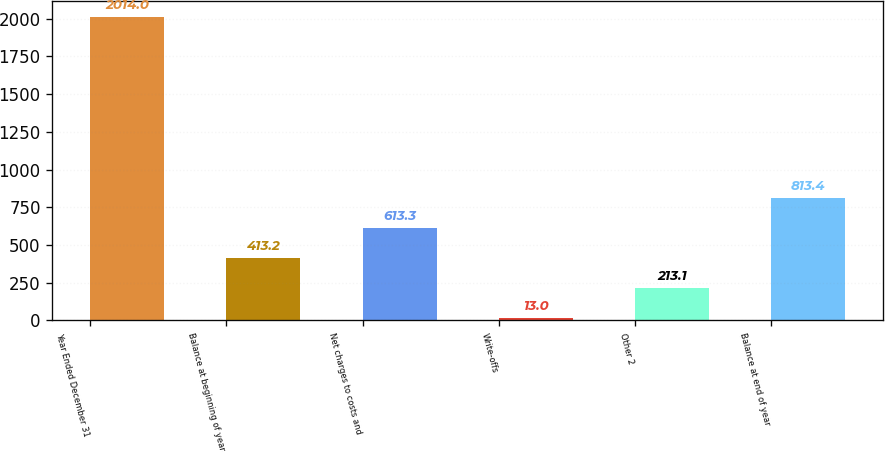Convert chart to OTSL. <chart><loc_0><loc_0><loc_500><loc_500><bar_chart><fcel>Year Ended December 31<fcel>Balance at beginning of year<fcel>Net charges to costs and<fcel>Write-offs<fcel>Other 2<fcel>Balance at end of year<nl><fcel>2014<fcel>413.2<fcel>613.3<fcel>13<fcel>213.1<fcel>813.4<nl></chart> 